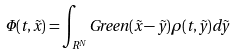Convert formula to latex. <formula><loc_0><loc_0><loc_500><loc_500>{ \Phi ( t , \vec { x } ) = } \int _ { R ^ { N } } G r e e n ( \vec { x } - \vec { y } ) \rho ( t , \vec { y } ) { d \vec { y } }</formula> 